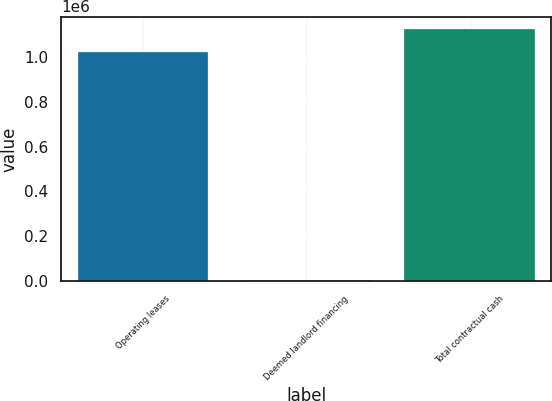Convert chart. <chart><loc_0><loc_0><loc_500><loc_500><bar_chart><fcel>Operating leases<fcel>Deemed landlord financing<fcel>Total contractual cash<nl><fcel>1.02085e+06<fcel>5504<fcel>1.12294e+06<nl></chart> 